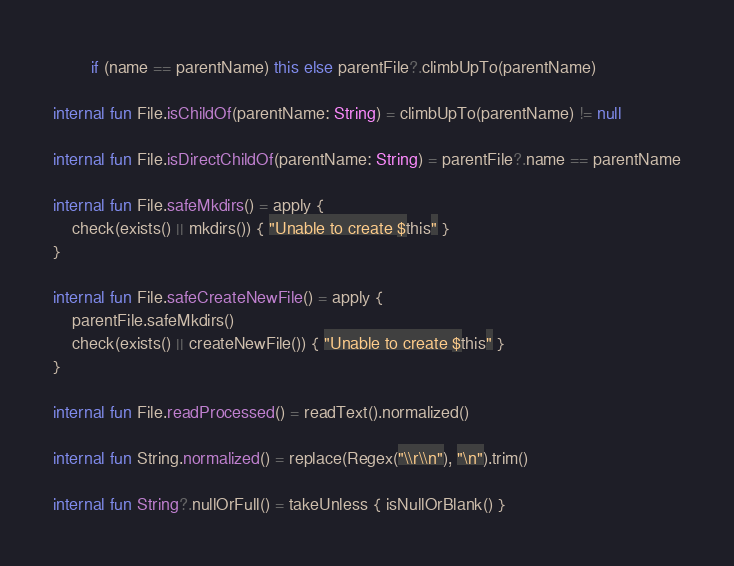Convert code to text. <code><loc_0><loc_0><loc_500><loc_500><_Kotlin_>        if (name == parentName) this else parentFile?.climbUpTo(parentName)

internal fun File.isChildOf(parentName: String) = climbUpTo(parentName) != null

internal fun File.isDirectChildOf(parentName: String) = parentFile?.name == parentName

internal fun File.safeMkdirs() = apply {
    check(exists() || mkdirs()) { "Unable to create $this" }
}

internal fun File.safeCreateNewFile() = apply {
    parentFile.safeMkdirs()
    check(exists() || createNewFile()) { "Unable to create $this" }
}

internal fun File.readProcessed() = readText().normalized()

internal fun String.normalized() = replace(Regex("\\r\\n"), "\n").trim()

internal fun String?.nullOrFull() = takeUnless { isNullOrBlank() }
</code> 